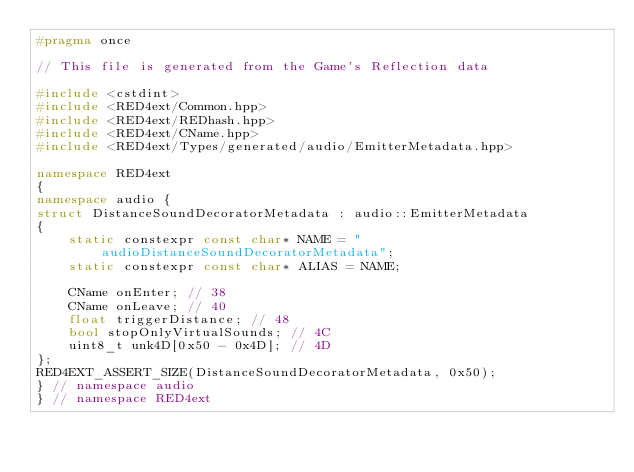Convert code to text. <code><loc_0><loc_0><loc_500><loc_500><_C++_>#pragma once

// This file is generated from the Game's Reflection data

#include <cstdint>
#include <RED4ext/Common.hpp>
#include <RED4ext/REDhash.hpp>
#include <RED4ext/CName.hpp>
#include <RED4ext/Types/generated/audio/EmitterMetadata.hpp>

namespace RED4ext
{
namespace audio { 
struct DistanceSoundDecoratorMetadata : audio::EmitterMetadata
{
    static constexpr const char* NAME = "audioDistanceSoundDecoratorMetadata";
    static constexpr const char* ALIAS = NAME;

    CName onEnter; // 38
    CName onLeave; // 40
    float triggerDistance; // 48
    bool stopOnlyVirtualSounds; // 4C
    uint8_t unk4D[0x50 - 0x4D]; // 4D
};
RED4EXT_ASSERT_SIZE(DistanceSoundDecoratorMetadata, 0x50);
} // namespace audio
} // namespace RED4ext
</code> 